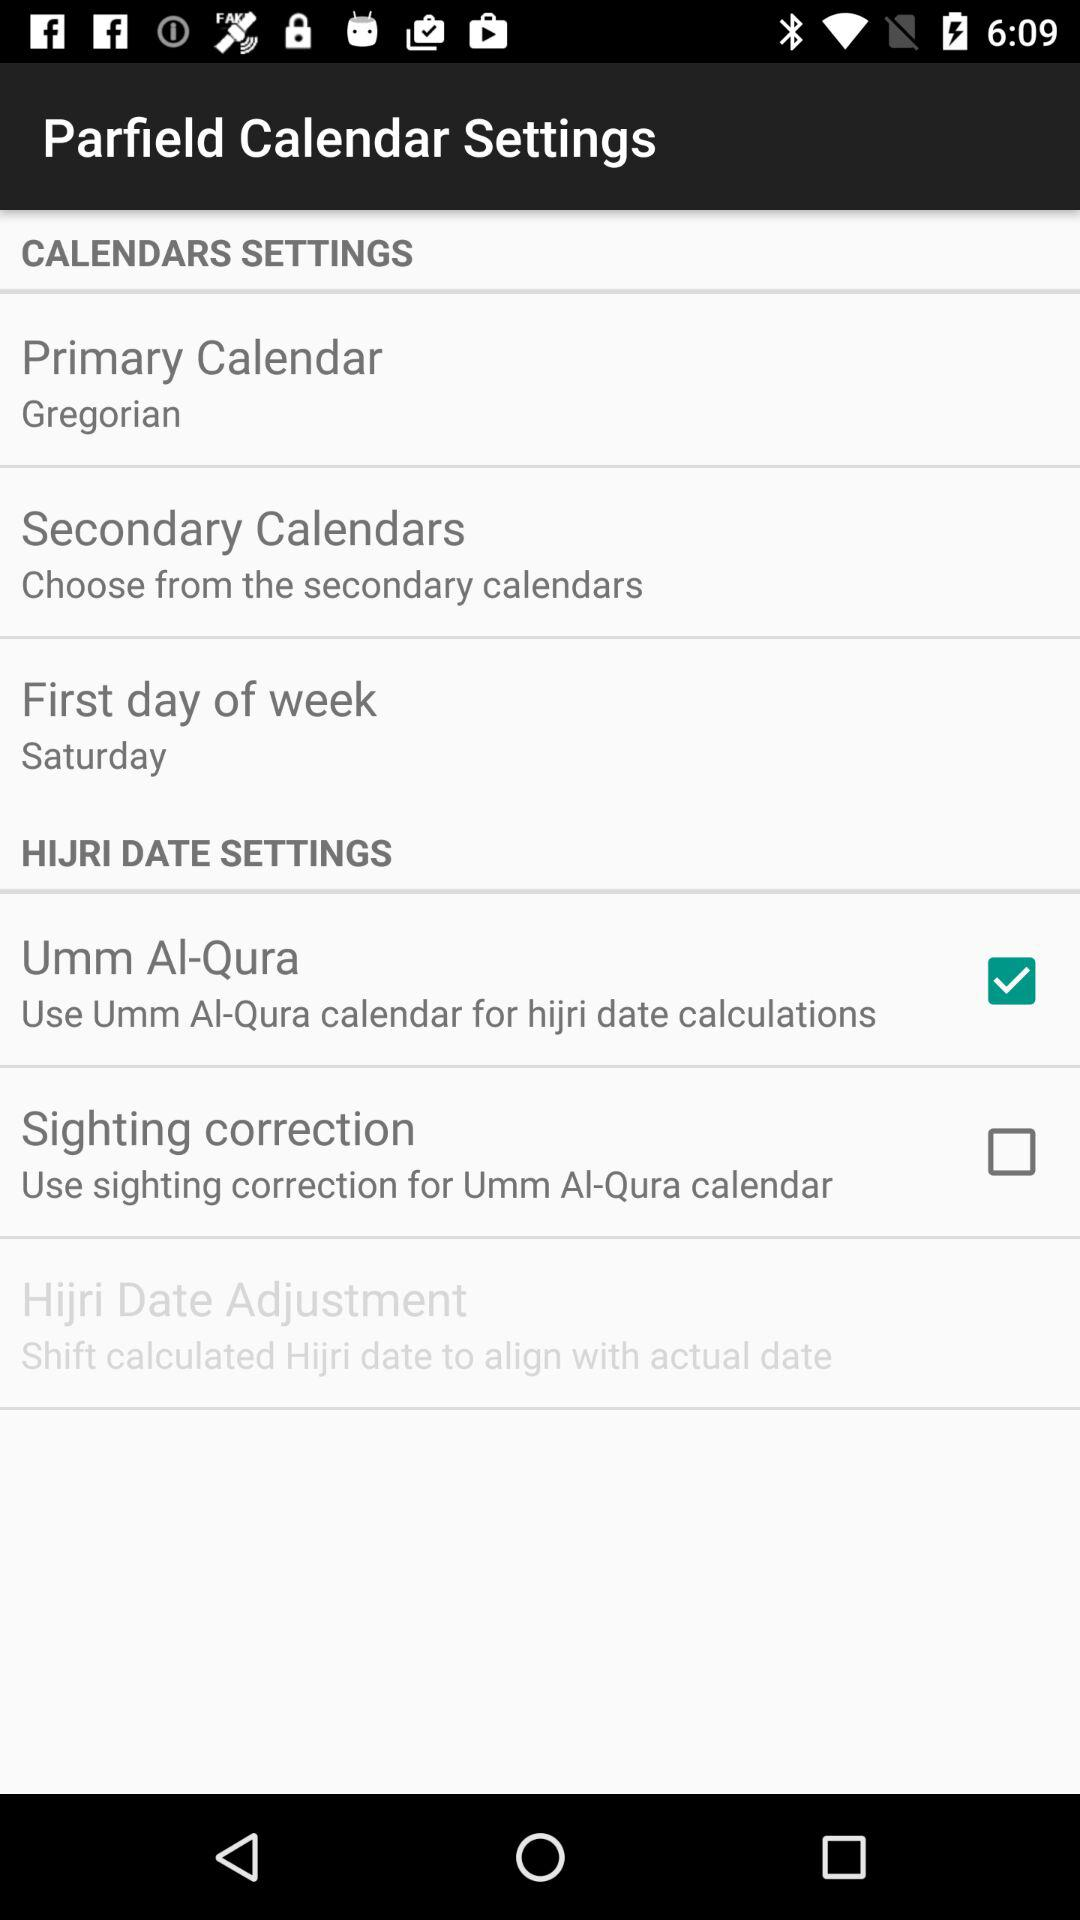What day is selected as the first day of the week? The selected day is Saturday. 